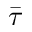<formula> <loc_0><loc_0><loc_500><loc_500>\bar { \tau }</formula> 